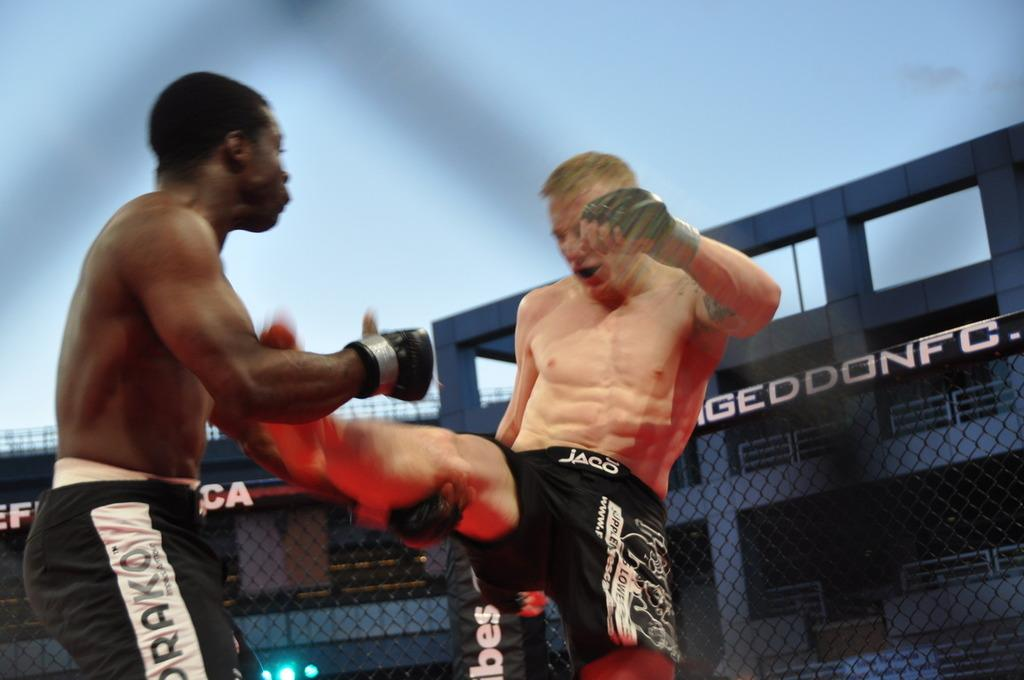<image>
Present a compact description of the photo's key features. An ongoing fight during a match sponsored by the Armageddon Fighting Championship 